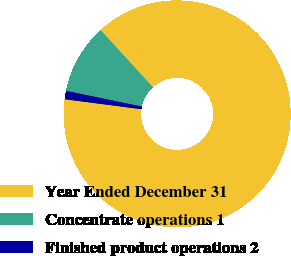Convert chart. <chart><loc_0><loc_0><loc_500><loc_500><pie_chart><fcel>Year Ended December 31<fcel>Concentrate operations 1<fcel>Finished product operations 2<nl><fcel>88.85%<fcel>9.96%<fcel>1.19%<nl></chart> 